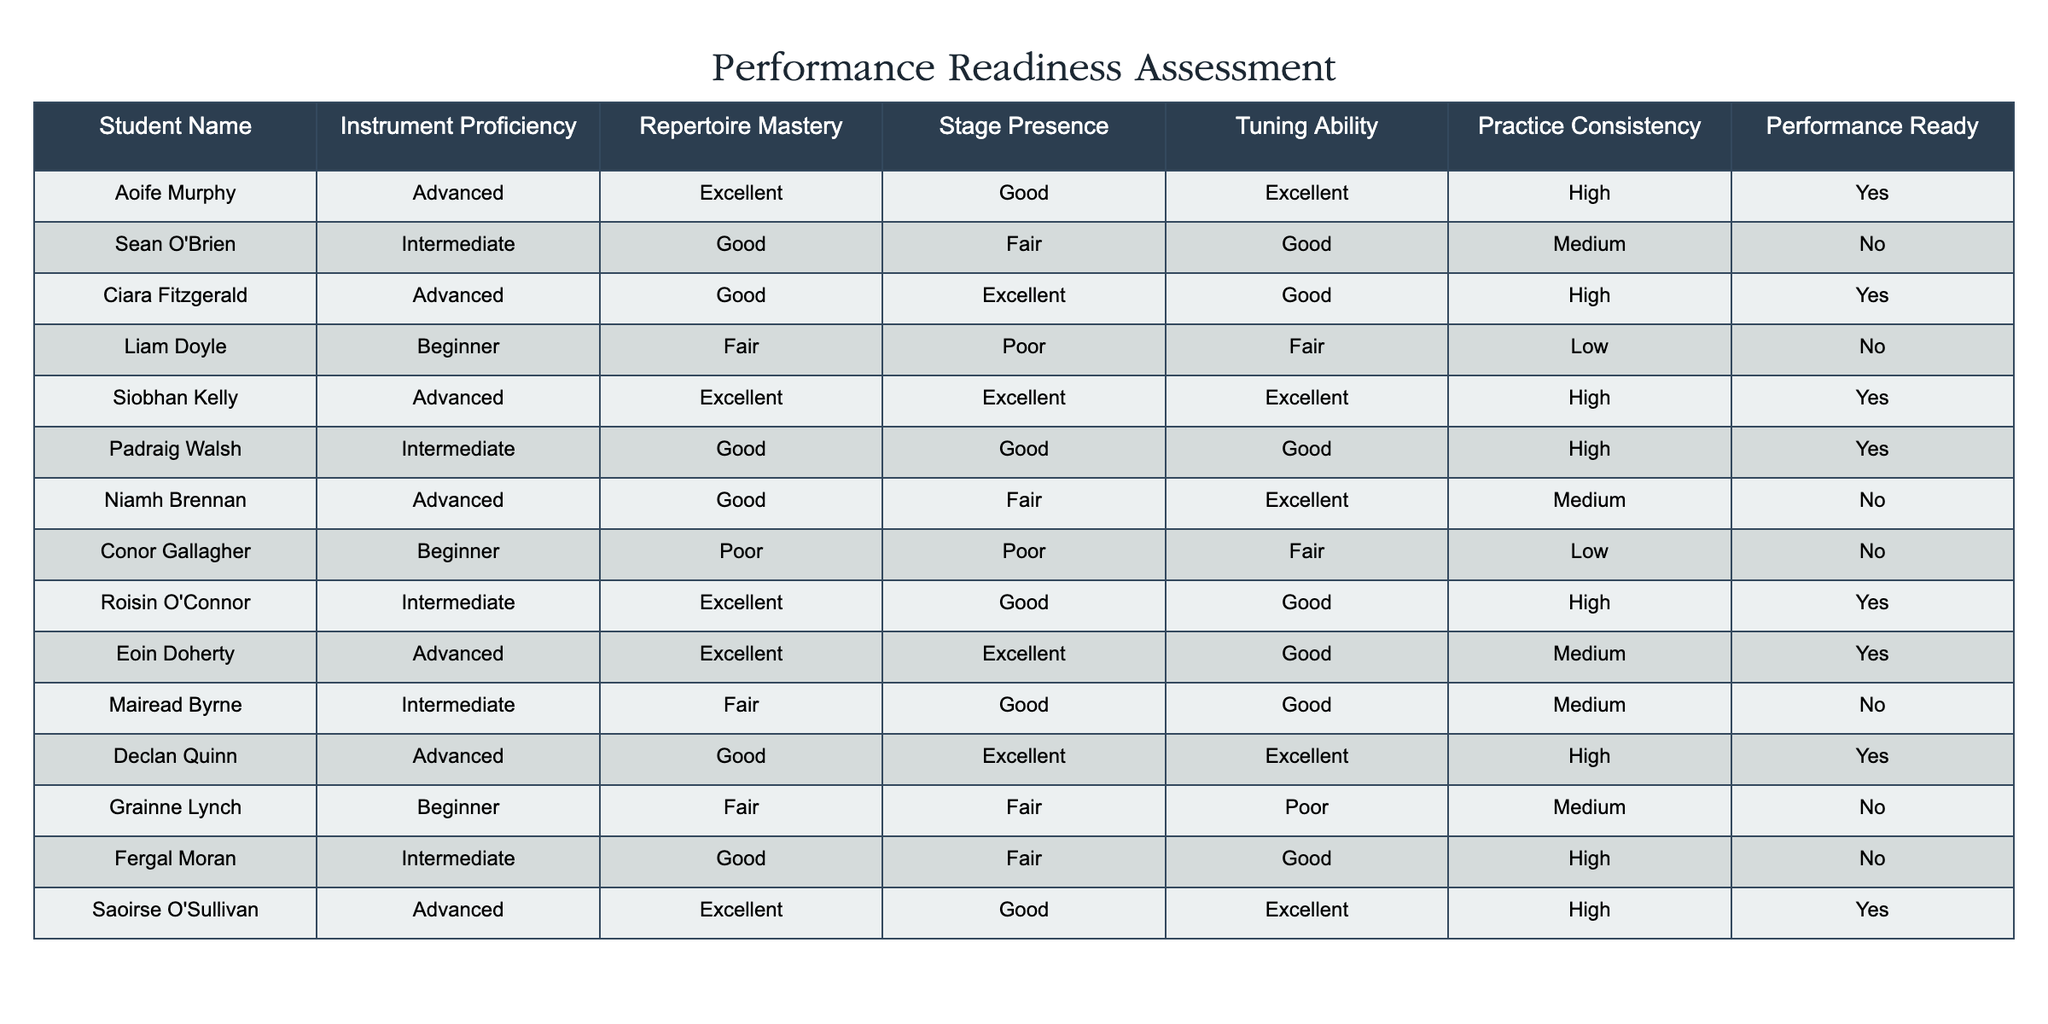What percentage of students are performance ready? There are 14 students in total, and 8 of them are marked as performance ready. To calculate the percentage, divide the number of performance ready students (8) by the total number of students (14) and multiply by 100. Thus, (8/14) * 100 = approximately 57.14%.
Answer: 57.14% How many students are classified as Intermediate proficiency? Looking at the table, there are 5 students classified as Intermediate proficiency: Sean O'Brien, Padraig Walsh, Roisin O'Connor, Mairead Byrne, and Fergal Moran.
Answer: 5 Is Saoirse O'Sullivan performance ready? Yes, according to the table, Saoirse O'Sullivan is marked as performance ready.
Answer: Yes What is the average tuning ability among Advanced students? There are 6 Advanced students: Aoife Murphy, Ciara Fitzgerald, Siobhan Kelly, Eoin Doherty, Declan Quinn, and Saoirse O'Sullivan. Their tuning abilities are Excellent, Good, Excellent, Good, Excellent, and Excellent. Converting these to numerical values (Excellent=3, Good=2, Fair=1, Poor=0), we get 3, 2, 3, 2, 3, 3. The sum is 16 and divided by 6 gives an average of approximately 2.67, or 2.7 when rounded.
Answer: 2.7 Which student has the lowest practice consistency? By examining the 'Practice Consistency' column, Liam Doyle and Conor Gallagher both have a Low rating. However, since only one person is needed, one can just choose Liam Doyle, as he is listed first in the table among those with Low consistency.
Answer: Liam Doyle 